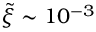Convert formula to latex. <formula><loc_0><loc_0><loc_500><loc_500>\tilde { \xi } \sim 1 0 ^ { - 3 }</formula> 